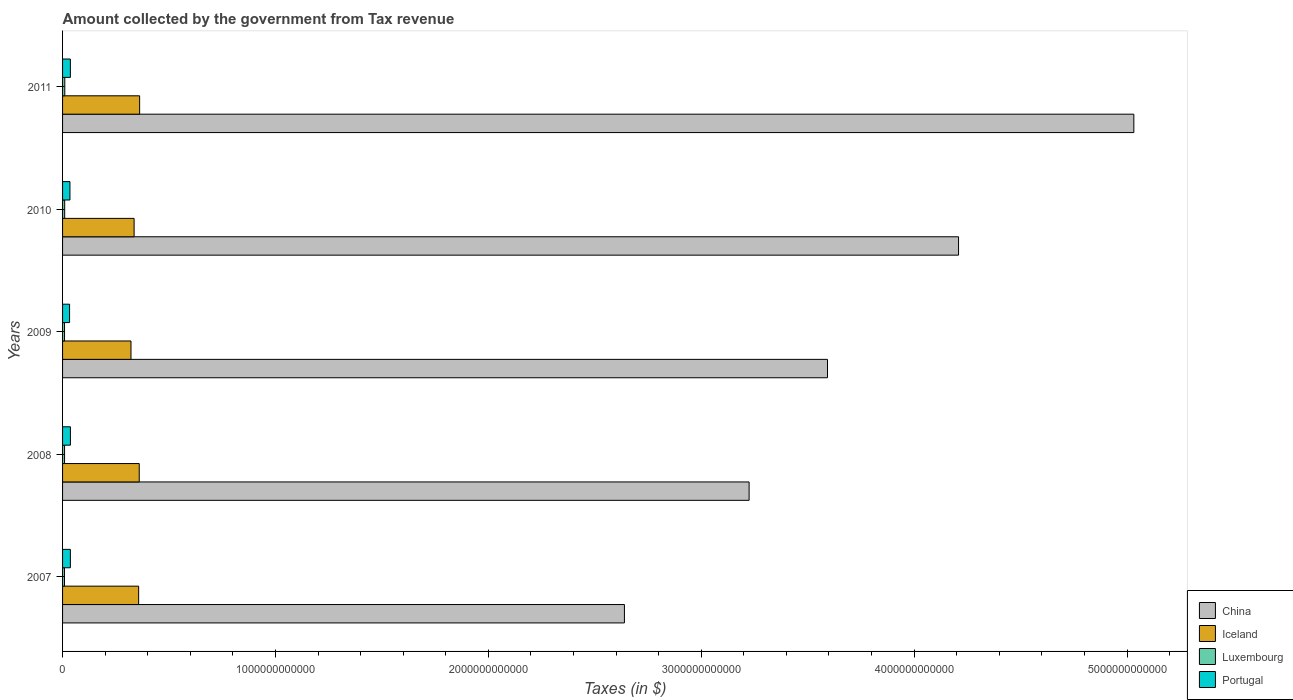How many groups of bars are there?
Provide a short and direct response. 5. Are the number of bars per tick equal to the number of legend labels?
Provide a succinct answer. Yes. Are the number of bars on each tick of the Y-axis equal?
Offer a very short reply. Yes. How many bars are there on the 3rd tick from the top?
Offer a terse response. 4. How many bars are there on the 3rd tick from the bottom?
Your answer should be very brief. 4. What is the label of the 1st group of bars from the top?
Offer a very short reply. 2011. In how many cases, is the number of bars for a given year not equal to the number of legend labels?
Give a very brief answer. 0. What is the amount collected by the government from tax revenue in Portugal in 2008?
Keep it short and to the point. 3.69e+1. Across all years, what is the maximum amount collected by the government from tax revenue in China?
Provide a succinct answer. 5.03e+12. Across all years, what is the minimum amount collected by the government from tax revenue in Portugal?
Give a very brief answer. 3.30e+1. What is the total amount collected by the government from tax revenue in Portugal in the graph?
Make the answer very short. 1.78e+11. What is the difference between the amount collected by the government from tax revenue in China in 2007 and that in 2010?
Keep it short and to the point. -1.57e+12. What is the difference between the amount collected by the government from tax revenue in Portugal in 2011 and the amount collected by the government from tax revenue in Iceland in 2008?
Provide a succinct answer. -3.23e+11. What is the average amount collected by the government from tax revenue in Luxembourg per year?
Your response must be concise. 9.60e+09. In the year 2009, what is the difference between the amount collected by the government from tax revenue in Portugal and amount collected by the government from tax revenue in Luxembourg?
Give a very brief answer. 2.37e+1. In how many years, is the amount collected by the government from tax revenue in Luxembourg greater than 3800000000000 $?
Provide a succinct answer. 0. What is the ratio of the amount collected by the government from tax revenue in Luxembourg in 2007 to that in 2008?
Give a very brief answer. 0.96. What is the difference between the highest and the second highest amount collected by the government from tax revenue in Portugal?
Your answer should be very brief. 1.94e+08. What is the difference between the highest and the lowest amount collected by the government from tax revenue in Luxembourg?
Give a very brief answer. 1.46e+09. Is the sum of the amount collected by the government from tax revenue in Iceland in 2009 and 2011 greater than the maximum amount collected by the government from tax revenue in Portugal across all years?
Provide a short and direct response. Yes. What does the 4th bar from the bottom in 2008 represents?
Keep it short and to the point. Portugal. How many bars are there?
Make the answer very short. 20. Are all the bars in the graph horizontal?
Provide a succinct answer. Yes. How many years are there in the graph?
Keep it short and to the point. 5. What is the difference between two consecutive major ticks on the X-axis?
Keep it short and to the point. 1.00e+12. Are the values on the major ticks of X-axis written in scientific E-notation?
Provide a short and direct response. No. What is the title of the graph?
Offer a terse response. Amount collected by the government from Tax revenue. Does "North America" appear as one of the legend labels in the graph?
Ensure brevity in your answer.  No. What is the label or title of the X-axis?
Your answer should be very brief. Taxes (in $). What is the label or title of the Y-axis?
Make the answer very short. Years. What is the Taxes (in $) in China in 2007?
Provide a short and direct response. 2.64e+12. What is the Taxes (in $) of Iceland in 2007?
Your answer should be very brief. 3.57e+11. What is the Taxes (in $) of Luxembourg in 2007?
Offer a very short reply. 9.00e+09. What is the Taxes (in $) of Portugal in 2007?
Provide a succinct answer. 3.67e+1. What is the Taxes (in $) of China in 2008?
Provide a short and direct response. 3.22e+12. What is the Taxes (in $) of Iceland in 2008?
Ensure brevity in your answer.  3.60e+11. What is the Taxes (in $) in Luxembourg in 2008?
Provide a succinct answer. 9.34e+09. What is the Taxes (in $) in Portugal in 2008?
Offer a terse response. 3.69e+1. What is the Taxes (in $) of China in 2009?
Ensure brevity in your answer.  3.59e+12. What is the Taxes (in $) in Iceland in 2009?
Give a very brief answer. 3.21e+11. What is the Taxes (in $) in Luxembourg in 2009?
Your answer should be compact. 9.25e+09. What is the Taxes (in $) of Portugal in 2009?
Your answer should be very brief. 3.30e+1. What is the Taxes (in $) of China in 2010?
Offer a terse response. 4.21e+12. What is the Taxes (in $) of Iceland in 2010?
Offer a very short reply. 3.36e+11. What is the Taxes (in $) in Luxembourg in 2010?
Make the answer very short. 9.93e+09. What is the Taxes (in $) in Portugal in 2010?
Provide a short and direct response. 3.47e+1. What is the Taxes (in $) of China in 2011?
Offer a terse response. 5.03e+12. What is the Taxes (in $) in Iceland in 2011?
Your answer should be compact. 3.62e+11. What is the Taxes (in $) in Luxembourg in 2011?
Keep it short and to the point. 1.05e+1. What is the Taxes (in $) of Portugal in 2011?
Your answer should be very brief. 3.67e+1. Across all years, what is the maximum Taxes (in $) of China?
Your response must be concise. 5.03e+12. Across all years, what is the maximum Taxes (in $) in Iceland?
Offer a very short reply. 3.62e+11. Across all years, what is the maximum Taxes (in $) of Luxembourg?
Make the answer very short. 1.05e+1. Across all years, what is the maximum Taxes (in $) in Portugal?
Your response must be concise. 3.69e+1. Across all years, what is the minimum Taxes (in $) of China?
Your response must be concise. 2.64e+12. Across all years, what is the minimum Taxes (in $) of Iceland?
Provide a succinct answer. 3.21e+11. Across all years, what is the minimum Taxes (in $) in Luxembourg?
Your response must be concise. 9.00e+09. Across all years, what is the minimum Taxes (in $) in Portugal?
Offer a terse response. 3.30e+1. What is the total Taxes (in $) of China in the graph?
Make the answer very short. 1.87e+13. What is the total Taxes (in $) of Iceland in the graph?
Give a very brief answer. 1.74e+12. What is the total Taxes (in $) of Luxembourg in the graph?
Keep it short and to the point. 4.80e+1. What is the total Taxes (in $) of Portugal in the graph?
Ensure brevity in your answer.  1.78e+11. What is the difference between the Taxes (in $) in China in 2007 and that in 2008?
Your response must be concise. -5.86e+11. What is the difference between the Taxes (in $) in Iceland in 2007 and that in 2008?
Keep it short and to the point. -2.79e+09. What is the difference between the Taxes (in $) of Luxembourg in 2007 and that in 2008?
Provide a short and direct response. -3.40e+08. What is the difference between the Taxes (in $) in Portugal in 2007 and that in 2008?
Give a very brief answer. -1.94e+08. What is the difference between the Taxes (in $) of China in 2007 and that in 2009?
Give a very brief answer. -9.54e+11. What is the difference between the Taxes (in $) in Iceland in 2007 and that in 2009?
Keep it short and to the point. 3.60e+1. What is the difference between the Taxes (in $) in Luxembourg in 2007 and that in 2009?
Ensure brevity in your answer.  -2.45e+08. What is the difference between the Taxes (in $) in Portugal in 2007 and that in 2009?
Keep it short and to the point. 3.73e+09. What is the difference between the Taxes (in $) of China in 2007 and that in 2010?
Offer a terse response. -1.57e+12. What is the difference between the Taxes (in $) in Iceland in 2007 and that in 2010?
Offer a very short reply. 2.13e+1. What is the difference between the Taxes (in $) of Luxembourg in 2007 and that in 2010?
Provide a short and direct response. -9.30e+08. What is the difference between the Taxes (in $) in Portugal in 2007 and that in 2010?
Give a very brief answer. 1.97e+09. What is the difference between the Taxes (in $) of China in 2007 and that in 2011?
Offer a terse response. -2.39e+12. What is the difference between the Taxes (in $) of Iceland in 2007 and that in 2011?
Offer a terse response. -4.62e+09. What is the difference between the Taxes (in $) of Luxembourg in 2007 and that in 2011?
Provide a short and direct response. -1.46e+09. What is the difference between the Taxes (in $) of Portugal in 2007 and that in 2011?
Provide a short and direct response. 2.07e+07. What is the difference between the Taxes (in $) in China in 2008 and that in 2009?
Make the answer very short. -3.68e+11. What is the difference between the Taxes (in $) of Iceland in 2008 and that in 2009?
Give a very brief answer. 3.88e+1. What is the difference between the Taxes (in $) in Luxembourg in 2008 and that in 2009?
Your answer should be compact. 9.52e+07. What is the difference between the Taxes (in $) of Portugal in 2008 and that in 2009?
Offer a terse response. 3.93e+09. What is the difference between the Taxes (in $) of China in 2008 and that in 2010?
Offer a terse response. -9.84e+11. What is the difference between the Taxes (in $) of Iceland in 2008 and that in 2010?
Your answer should be very brief. 2.41e+1. What is the difference between the Taxes (in $) in Luxembourg in 2008 and that in 2010?
Your answer should be very brief. -5.90e+08. What is the difference between the Taxes (in $) in Portugal in 2008 and that in 2010?
Your response must be concise. 2.16e+09. What is the difference between the Taxes (in $) of China in 2008 and that in 2011?
Offer a terse response. -1.81e+12. What is the difference between the Taxes (in $) in Iceland in 2008 and that in 2011?
Your answer should be compact. -1.84e+09. What is the difference between the Taxes (in $) of Luxembourg in 2008 and that in 2011?
Your response must be concise. -1.12e+09. What is the difference between the Taxes (in $) of Portugal in 2008 and that in 2011?
Keep it short and to the point. 2.15e+08. What is the difference between the Taxes (in $) of China in 2009 and that in 2010?
Give a very brief answer. -6.16e+11. What is the difference between the Taxes (in $) of Iceland in 2009 and that in 2010?
Keep it short and to the point. -1.47e+1. What is the difference between the Taxes (in $) in Luxembourg in 2009 and that in 2010?
Offer a very short reply. -6.85e+08. What is the difference between the Taxes (in $) of Portugal in 2009 and that in 2010?
Your answer should be very brief. -1.77e+09. What is the difference between the Taxes (in $) of China in 2009 and that in 2011?
Your response must be concise. -1.44e+12. What is the difference between the Taxes (in $) in Iceland in 2009 and that in 2011?
Keep it short and to the point. -4.06e+1. What is the difference between the Taxes (in $) of Luxembourg in 2009 and that in 2011?
Offer a terse response. -1.22e+09. What is the difference between the Taxes (in $) in Portugal in 2009 and that in 2011?
Offer a very short reply. -3.71e+09. What is the difference between the Taxes (in $) in China in 2010 and that in 2011?
Offer a terse response. -8.23e+11. What is the difference between the Taxes (in $) in Iceland in 2010 and that in 2011?
Give a very brief answer. -2.59e+1. What is the difference between the Taxes (in $) of Luxembourg in 2010 and that in 2011?
Provide a short and direct response. -5.33e+08. What is the difference between the Taxes (in $) of Portugal in 2010 and that in 2011?
Your response must be concise. -1.95e+09. What is the difference between the Taxes (in $) of China in 2007 and the Taxes (in $) of Iceland in 2008?
Give a very brief answer. 2.28e+12. What is the difference between the Taxes (in $) in China in 2007 and the Taxes (in $) in Luxembourg in 2008?
Make the answer very short. 2.63e+12. What is the difference between the Taxes (in $) of China in 2007 and the Taxes (in $) of Portugal in 2008?
Offer a terse response. 2.60e+12. What is the difference between the Taxes (in $) of Iceland in 2007 and the Taxes (in $) of Luxembourg in 2008?
Give a very brief answer. 3.48e+11. What is the difference between the Taxes (in $) of Iceland in 2007 and the Taxes (in $) of Portugal in 2008?
Keep it short and to the point. 3.20e+11. What is the difference between the Taxes (in $) in Luxembourg in 2007 and the Taxes (in $) in Portugal in 2008?
Your answer should be very brief. -2.79e+1. What is the difference between the Taxes (in $) of China in 2007 and the Taxes (in $) of Iceland in 2009?
Give a very brief answer. 2.32e+12. What is the difference between the Taxes (in $) in China in 2007 and the Taxes (in $) in Luxembourg in 2009?
Your response must be concise. 2.63e+12. What is the difference between the Taxes (in $) of China in 2007 and the Taxes (in $) of Portugal in 2009?
Ensure brevity in your answer.  2.61e+12. What is the difference between the Taxes (in $) of Iceland in 2007 and the Taxes (in $) of Luxembourg in 2009?
Offer a very short reply. 3.48e+11. What is the difference between the Taxes (in $) of Iceland in 2007 and the Taxes (in $) of Portugal in 2009?
Give a very brief answer. 3.24e+11. What is the difference between the Taxes (in $) of Luxembourg in 2007 and the Taxes (in $) of Portugal in 2009?
Your answer should be compact. -2.40e+1. What is the difference between the Taxes (in $) in China in 2007 and the Taxes (in $) in Iceland in 2010?
Ensure brevity in your answer.  2.30e+12. What is the difference between the Taxes (in $) in China in 2007 and the Taxes (in $) in Luxembourg in 2010?
Your response must be concise. 2.63e+12. What is the difference between the Taxes (in $) of China in 2007 and the Taxes (in $) of Portugal in 2010?
Make the answer very short. 2.60e+12. What is the difference between the Taxes (in $) of Iceland in 2007 and the Taxes (in $) of Luxembourg in 2010?
Offer a terse response. 3.47e+11. What is the difference between the Taxes (in $) in Iceland in 2007 and the Taxes (in $) in Portugal in 2010?
Your answer should be compact. 3.23e+11. What is the difference between the Taxes (in $) of Luxembourg in 2007 and the Taxes (in $) of Portugal in 2010?
Provide a short and direct response. -2.57e+1. What is the difference between the Taxes (in $) in China in 2007 and the Taxes (in $) in Iceland in 2011?
Ensure brevity in your answer.  2.28e+12. What is the difference between the Taxes (in $) of China in 2007 and the Taxes (in $) of Luxembourg in 2011?
Provide a succinct answer. 2.63e+12. What is the difference between the Taxes (in $) of China in 2007 and the Taxes (in $) of Portugal in 2011?
Offer a terse response. 2.60e+12. What is the difference between the Taxes (in $) of Iceland in 2007 and the Taxes (in $) of Luxembourg in 2011?
Your answer should be compact. 3.47e+11. What is the difference between the Taxes (in $) in Iceland in 2007 and the Taxes (in $) in Portugal in 2011?
Offer a very short reply. 3.21e+11. What is the difference between the Taxes (in $) of Luxembourg in 2007 and the Taxes (in $) of Portugal in 2011?
Give a very brief answer. -2.77e+1. What is the difference between the Taxes (in $) of China in 2008 and the Taxes (in $) of Iceland in 2009?
Your answer should be very brief. 2.90e+12. What is the difference between the Taxes (in $) in China in 2008 and the Taxes (in $) in Luxembourg in 2009?
Your answer should be very brief. 3.22e+12. What is the difference between the Taxes (in $) in China in 2008 and the Taxes (in $) in Portugal in 2009?
Provide a short and direct response. 3.19e+12. What is the difference between the Taxes (in $) in Iceland in 2008 and the Taxes (in $) in Luxembourg in 2009?
Offer a very short reply. 3.51e+11. What is the difference between the Taxes (in $) of Iceland in 2008 and the Taxes (in $) of Portugal in 2009?
Keep it short and to the point. 3.27e+11. What is the difference between the Taxes (in $) in Luxembourg in 2008 and the Taxes (in $) in Portugal in 2009?
Provide a short and direct response. -2.36e+1. What is the difference between the Taxes (in $) in China in 2008 and the Taxes (in $) in Iceland in 2010?
Your answer should be compact. 2.89e+12. What is the difference between the Taxes (in $) of China in 2008 and the Taxes (in $) of Luxembourg in 2010?
Keep it short and to the point. 3.21e+12. What is the difference between the Taxes (in $) of China in 2008 and the Taxes (in $) of Portugal in 2010?
Make the answer very short. 3.19e+12. What is the difference between the Taxes (in $) of Iceland in 2008 and the Taxes (in $) of Luxembourg in 2010?
Provide a short and direct response. 3.50e+11. What is the difference between the Taxes (in $) in Iceland in 2008 and the Taxes (in $) in Portugal in 2010?
Provide a short and direct response. 3.25e+11. What is the difference between the Taxes (in $) in Luxembourg in 2008 and the Taxes (in $) in Portugal in 2010?
Your answer should be very brief. -2.54e+1. What is the difference between the Taxes (in $) of China in 2008 and the Taxes (in $) of Iceland in 2011?
Provide a succinct answer. 2.86e+12. What is the difference between the Taxes (in $) in China in 2008 and the Taxes (in $) in Luxembourg in 2011?
Keep it short and to the point. 3.21e+12. What is the difference between the Taxes (in $) of China in 2008 and the Taxes (in $) of Portugal in 2011?
Provide a succinct answer. 3.19e+12. What is the difference between the Taxes (in $) of Iceland in 2008 and the Taxes (in $) of Luxembourg in 2011?
Offer a terse response. 3.50e+11. What is the difference between the Taxes (in $) in Iceland in 2008 and the Taxes (in $) in Portugal in 2011?
Provide a succinct answer. 3.23e+11. What is the difference between the Taxes (in $) of Luxembourg in 2008 and the Taxes (in $) of Portugal in 2011?
Make the answer very short. -2.73e+1. What is the difference between the Taxes (in $) in China in 2009 and the Taxes (in $) in Iceland in 2010?
Give a very brief answer. 3.26e+12. What is the difference between the Taxes (in $) of China in 2009 and the Taxes (in $) of Luxembourg in 2010?
Ensure brevity in your answer.  3.58e+12. What is the difference between the Taxes (in $) of China in 2009 and the Taxes (in $) of Portugal in 2010?
Your answer should be compact. 3.56e+12. What is the difference between the Taxes (in $) in Iceland in 2009 and the Taxes (in $) in Luxembourg in 2010?
Your response must be concise. 3.11e+11. What is the difference between the Taxes (in $) in Iceland in 2009 and the Taxes (in $) in Portugal in 2010?
Offer a terse response. 2.87e+11. What is the difference between the Taxes (in $) of Luxembourg in 2009 and the Taxes (in $) of Portugal in 2010?
Your answer should be very brief. -2.55e+1. What is the difference between the Taxes (in $) in China in 2009 and the Taxes (in $) in Iceland in 2011?
Ensure brevity in your answer.  3.23e+12. What is the difference between the Taxes (in $) in China in 2009 and the Taxes (in $) in Luxembourg in 2011?
Your answer should be very brief. 3.58e+12. What is the difference between the Taxes (in $) of China in 2009 and the Taxes (in $) of Portugal in 2011?
Your answer should be compact. 3.56e+12. What is the difference between the Taxes (in $) in Iceland in 2009 and the Taxes (in $) in Luxembourg in 2011?
Your answer should be compact. 3.11e+11. What is the difference between the Taxes (in $) of Iceland in 2009 and the Taxes (in $) of Portugal in 2011?
Ensure brevity in your answer.  2.85e+11. What is the difference between the Taxes (in $) of Luxembourg in 2009 and the Taxes (in $) of Portugal in 2011?
Your answer should be compact. -2.74e+1. What is the difference between the Taxes (in $) of China in 2010 and the Taxes (in $) of Iceland in 2011?
Provide a succinct answer. 3.85e+12. What is the difference between the Taxes (in $) in China in 2010 and the Taxes (in $) in Luxembourg in 2011?
Your answer should be very brief. 4.20e+12. What is the difference between the Taxes (in $) of China in 2010 and the Taxes (in $) of Portugal in 2011?
Provide a short and direct response. 4.17e+12. What is the difference between the Taxes (in $) in Iceland in 2010 and the Taxes (in $) in Luxembourg in 2011?
Your answer should be compact. 3.26e+11. What is the difference between the Taxes (in $) in Iceland in 2010 and the Taxes (in $) in Portugal in 2011?
Keep it short and to the point. 2.99e+11. What is the difference between the Taxes (in $) in Luxembourg in 2010 and the Taxes (in $) in Portugal in 2011?
Your answer should be compact. -2.67e+1. What is the average Taxes (in $) in China per year?
Give a very brief answer. 3.74e+12. What is the average Taxes (in $) in Iceland per year?
Keep it short and to the point. 3.47e+11. What is the average Taxes (in $) of Luxembourg per year?
Give a very brief answer. 9.60e+09. What is the average Taxes (in $) of Portugal per year?
Your answer should be compact. 3.56e+1. In the year 2007, what is the difference between the Taxes (in $) of China and Taxes (in $) of Iceland?
Ensure brevity in your answer.  2.28e+12. In the year 2007, what is the difference between the Taxes (in $) in China and Taxes (in $) in Luxembourg?
Ensure brevity in your answer.  2.63e+12. In the year 2007, what is the difference between the Taxes (in $) of China and Taxes (in $) of Portugal?
Your answer should be compact. 2.60e+12. In the year 2007, what is the difference between the Taxes (in $) of Iceland and Taxes (in $) of Luxembourg?
Provide a succinct answer. 3.48e+11. In the year 2007, what is the difference between the Taxes (in $) in Iceland and Taxes (in $) in Portugal?
Your answer should be very brief. 3.21e+11. In the year 2007, what is the difference between the Taxes (in $) in Luxembourg and Taxes (in $) in Portugal?
Provide a short and direct response. -2.77e+1. In the year 2008, what is the difference between the Taxes (in $) of China and Taxes (in $) of Iceland?
Give a very brief answer. 2.86e+12. In the year 2008, what is the difference between the Taxes (in $) of China and Taxes (in $) of Luxembourg?
Give a very brief answer. 3.22e+12. In the year 2008, what is the difference between the Taxes (in $) of China and Taxes (in $) of Portugal?
Your answer should be very brief. 3.19e+12. In the year 2008, what is the difference between the Taxes (in $) of Iceland and Taxes (in $) of Luxembourg?
Provide a succinct answer. 3.51e+11. In the year 2008, what is the difference between the Taxes (in $) in Iceland and Taxes (in $) in Portugal?
Provide a short and direct response. 3.23e+11. In the year 2008, what is the difference between the Taxes (in $) in Luxembourg and Taxes (in $) in Portugal?
Keep it short and to the point. -2.75e+1. In the year 2009, what is the difference between the Taxes (in $) in China and Taxes (in $) in Iceland?
Offer a terse response. 3.27e+12. In the year 2009, what is the difference between the Taxes (in $) in China and Taxes (in $) in Luxembourg?
Ensure brevity in your answer.  3.58e+12. In the year 2009, what is the difference between the Taxes (in $) of China and Taxes (in $) of Portugal?
Keep it short and to the point. 3.56e+12. In the year 2009, what is the difference between the Taxes (in $) in Iceland and Taxes (in $) in Luxembourg?
Your response must be concise. 3.12e+11. In the year 2009, what is the difference between the Taxes (in $) of Iceland and Taxes (in $) of Portugal?
Your answer should be compact. 2.88e+11. In the year 2009, what is the difference between the Taxes (in $) in Luxembourg and Taxes (in $) in Portugal?
Ensure brevity in your answer.  -2.37e+1. In the year 2010, what is the difference between the Taxes (in $) of China and Taxes (in $) of Iceland?
Provide a short and direct response. 3.87e+12. In the year 2010, what is the difference between the Taxes (in $) in China and Taxes (in $) in Luxembourg?
Make the answer very short. 4.20e+12. In the year 2010, what is the difference between the Taxes (in $) in China and Taxes (in $) in Portugal?
Provide a succinct answer. 4.17e+12. In the year 2010, what is the difference between the Taxes (in $) of Iceland and Taxes (in $) of Luxembourg?
Offer a terse response. 3.26e+11. In the year 2010, what is the difference between the Taxes (in $) in Iceland and Taxes (in $) in Portugal?
Your response must be concise. 3.01e+11. In the year 2010, what is the difference between the Taxes (in $) of Luxembourg and Taxes (in $) of Portugal?
Your response must be concise. -2.48e+1. In the year 2011, what is the difference between the Taxes (in $) of China and Taxes (in $) of Iceland?
Provide a succinct answer. 4.67e+12. In the year 2011, what is the difference between the Taxes (in $) of China and Taxes (in $) of Luxembourg?
Offer a very short reply. 5.02e+12. In the year 2011, what is the difference between the Taxes (in $) of China and Taxes (in $) of Portugal?
Give a very brief answer. 5.00e+12. In the year 2011, what is the difference between the Taxes (in $) in Iceland and Taxes (in $) in Luxembourg?
Provide a short and direct response. 3.52e+11. In the year 2011, what is the difference between the Taxes (in $) of Iceland and Taxes (in $) of Portugal?
Provide a short and direct response. 3.25e+11. In the year 2011, what is the difference between the Taxes (in $) in Luxembourg and Taxes (in $) in Portugal?
Provide a short and direct response. -2.62e+1. What is the ratio of the Taxes (in $) in China in 2007 to that in 2008?
Your response must be concise. 0.82. What is the ratio of the Taxes (in $) of Luxembourg in 2007 to that in 2008?
Give a very brief answer. 0.96. What is the ratio of the Taxes (in $) of Portugal in 2007 to that in 2008?
Provide a short and direct response. 0.99. What is the ratio of the Taxes (in $) in China in 2007 to that in 2009?
Your answer should be very brief. 0.73. What is the ratio of the Taxes (in $) of Iceland in 2007 to that in 2009?
Provide a short and direct response. 1.11. What is the ratio of the Taxes (in $) in Luxembourg in 2007 to that in 2009?
Keep it short and to the point. 0.97. What is the ratio of the Taxes (in $) of Portugal in 2007 to that in 2009?
Provide a short and direct response. 1.11. What is the ratio of the Taxes (in $) of China in 2007 to that in 2010?
Offer a very short reply. 0.63. What is the ratio of the Taxes (in $) in Iceland in 2007 to that in 2010?
Give a very brief answer. 1.06. What is the ratio of the Taxes (in $) of Luxembourg in 2007 to that in 2010?
Offer a very short reply. 0.91. What is the ratio of the Taxes (in $) in Portugal in 2007 to that in 2010?
Your answer should be very brief. 1.06. What is the ratio of the Taxes (in $) of China in 2007 to that in 2011?
Your answer should be compact. 0.52. What is the ratio of the Taxes (in $) in Iceland in 2007 to that in 2011?
Ensure brevity in your answer.  0.99. What is the ratio of the Taxes (in $) of Luxembourg in 2007 to that in 2011?
Your answer should be compact. 0.86. What is the ratio of the Taxes (in $) of Portugal in 2007 to that in 2011?
Offer a terse response. 1. What is the ratio of the Taxes (in $) of China in 2008 to that in 2009?
Make the answer very short. 0.9. What is the ratio of the Taxes (in $) of Iceland in 2008 to that in 2009?
Provide a succinct answer. 1.12. What is the ratio of the Taxes (in $) in Luxembourg in 2008 to that in 2009?
Keep it short and to the point. 1.01. What is the ratio of the Taxes (in $) in Portugal in 2008 to that in 2009?
Give a very brief answer. 1.12. What is the ratio of the Taxes (in $) of China in 2008 to that in 2010?
Your answer should be very brief. 0.77. What is the ratio of the Taxes (in $) in Iceland in 2008 to that in 2010?
Ensure brevity in your answer.  1.07. What is the ratio of the Taxes (in $) of Luxembourg in 2008 to that in 2010?
Keep it short and to the point. 0.94. What is the ratio of the Taxes (in $) of Portugal in 2008 to that in 2010?
Your response must be concise. 1.06. What is the ratio of the Taxes (in $) of China in 2008 to that in 2011?
Your response must be concise. 0.64. What is the ratio of the Taxes (in $) of Iceland in 2008 to that in 2011?
Ensure brevity in your answer.  0.99. What is the ratio of the Taxes (in $) of Luxembourg in 2008 to that in 2011?
Your answer should be very brief. 0.89. What is the ratio of the Taxes (in $) in Portugal in 2008 to that in 2011?
Provide a short and direct response. 1.01. What is the ratio of the Taxes (in $) of China in 2009 to that in 2010?
Your answer should be compact. 0.85. What is the ratio of the Taxes (in $) of Iceland in 2009 to that in 2010?
Keep it short and to the point. 0.96. What is the ratio of the Taxes (in $) of Portugal in 2009 to that in 2010?
Provide a succinct answer. 0.95. What is the ratio of the Taxes (in $) in China in 2009 to that in 2011?
Ensure brevity in your answer.  0.71. What is the ratio of the Taxes (in $) in Iceland in 2009 to that in 2011?
Offer a terse response. 0.89. What is the ratio of the Taxes (in $) in Luxembourg in 2009 to that in 2011?
Your answer should be compact. 0.88. What is the ratio of the Taxes (in $) of Portugal in 2009 to that in 2011?
Ensure brevity in your answer.  0.9. What is the ratio of the Taxes (in $) of China in 2010 to that in 2011?
Ensure brevity in your answer.  0.84. What is the ratio of the Taxes (in $) of Iceland in 2010 to that in 2011?
Your answer should be very brief. 0.93. What is the ratio of the Taxes (in $) of Luxembourg in 2010 to that in 2011?
Make the answer very short. 0.95. What is the ratio of the Taxes (in $) in Portugal in 2010 to that in 2011?
Give a very brief answer. 0.95. What is the difference between the highest and the second highest Taxes (in $) of China?
Provide a short and direct response. 8.23e+11. What is the difference between the highest and the second highest Taxes (in $) in Iceland?
Your answer should be very brief. 1.84e+09. What is the difference between the highest and the second highest Taxes (in $) of Luxembourg?
Provide a short and direct response. 5.33e+08. What is the difference between the highest and the second highest Taxes (in $) of Portugal?
Keep it short and to the point. 1.94e+08. What is the difference between the highest and the lowest Taxes (in $) of China?
Offer a very short reply. 2.39e+12. What is the difference between the highest and the lowest Taxes (in $) of Iceland?
Offer a very short reply. 4.06e+1. What is the difference between the highest and the lowest Taxes (in $) of Luxembourg?
Provide a short and direct response. 1.46e+09. What is the difference between the highest and the lowest Taxes (in $) in Portugal?
Provide a short and direct response. 3.93e+09. 